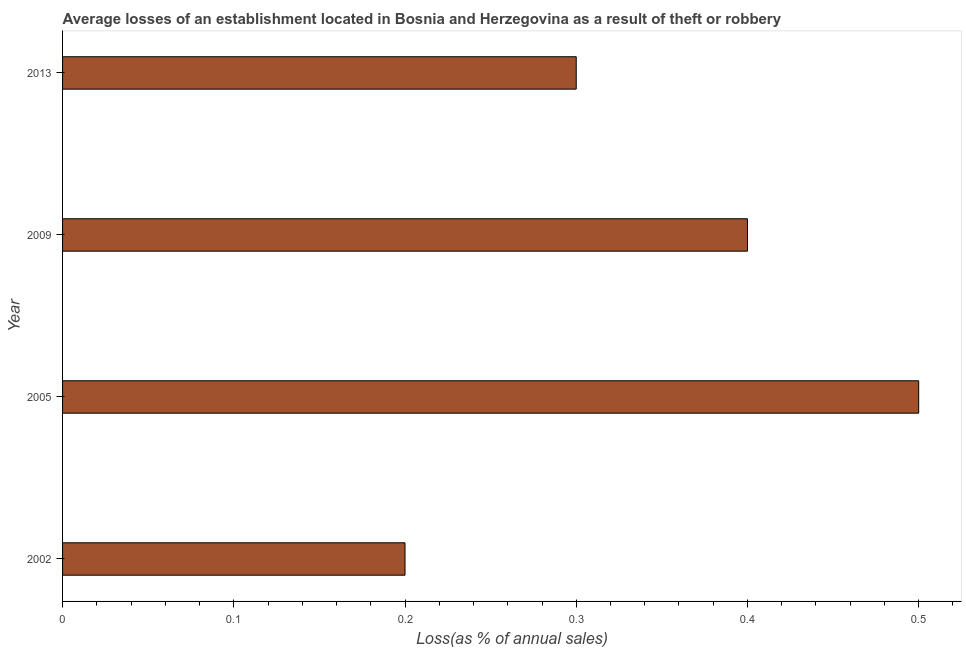Does the graph contain grids?
Offer a terse response. No. What is the title of the graph?
Give a very brief answer. Average losses of an establishment located in Bosnia and Herzegovina as a result of theft or robbery. What is the label or title of the X-axis?
Ensure brevity in your answer.  Loss(as % of annual sales). What is the losses due to theft in 2013?
Ensure brevity in your answer.  0.3. Across all years, what is the minimum losses due to theft?
Your response must be concise. 0.2. What is the sum of the losses due to theft?
Make the answer very short. 1.4. What is the difference between the losses due to theft in 2002 and 2005?
Your answer should be very brief. -0.3. What is the average losses due to theft per year?
Make the answer very short. 0.35. What is the median losses due to theft?
Offer a very short reply. 0.35. In how many years, is the losses due to theft greater than 0.34 %?
Your answer should be very brief. 2. What is the ratio of the losses due to theft in 2005 to that in 2009?
Provide a succinct answer. 1.25. Is the sum of the losses due to theft in 2002 and 2005 greater than the maximum losses due to theft across all years?
Ensure brevity in your answer.  Yes. What is the difference between the highest and the lowest losses due to theft?
Give a very brief answer. 0.3. How many bars are there?
Make the answer very short. 4. Are all the bars in the graph horizontal?
Provide a short and direct response. Yes. What is the difference between two consecutive major ticks on the X-axis?
Provide a short and direct response. 0.1. What is the Loss(as % of annual sales) in 2005?
Provide a succinct answer. 0.5. What is the Loss(as % of annual sales) in 2009?
Offer a terse response. 0.4. What is the Loss(as % of annual sales) in 2013?
Your response must be concise. 0.3. What is the difference between the Loss(as % of annual sales) in 2002 and 2009?
Provide a succinct answer. -0.2. What is the difference between the Loss(as % of annual sales) in 2002 and 2013?
Your answer should be very brief. -0.1. What is the difference between the Loss(as % of annual sales) in 2005 and 2009?
Give a very brief answer. 0.1. What is the difference between the Loss(as % of annual sales) in 2009 and 2013?
Offer a terse response. 0.1. What is the ratio of the Loss(as % of annual sales) in 2002 to that in 2005?
Provide a short and direct response. 0.4. What is the ratio of the Loss(as % of annual sales) in 2002 to that in 2013?
Offer a terse response. 0.67. What is the ratio of the Loss(as % of annual sales) in 2005 to that in 2013?
Offer a very short reply. 1.67. What is the ratio of the Loss(as % of annual sales) in 2009 to that in 2013?
Your answer should be compact. 1.33. 